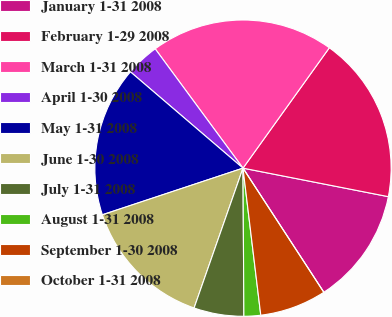<chart> <loc_0><loc_0><loc_500><loc_500><pie_chart><fcel>January 1-31 2008<fcel>February 1-29 2008<fcel>March 1-31 2008<fcel>April 1-30 2008<fcel>May 1-31 2008<fcel>June 1-30 2008<fcel>July 1-31 2008<fcel>August 1-31 2008<fcel>September 1-30 2008<fcel>October 1-31 2008<nl><fcel>12.73%<fcel>18.18%<fcel>20.0%<fcel>3.64%<fcel>16.36%<fcel>14.55%<fcel>5.45%<fcel>1.82%<fcel>7.27%<fcel>0.0%<nl></chart> 